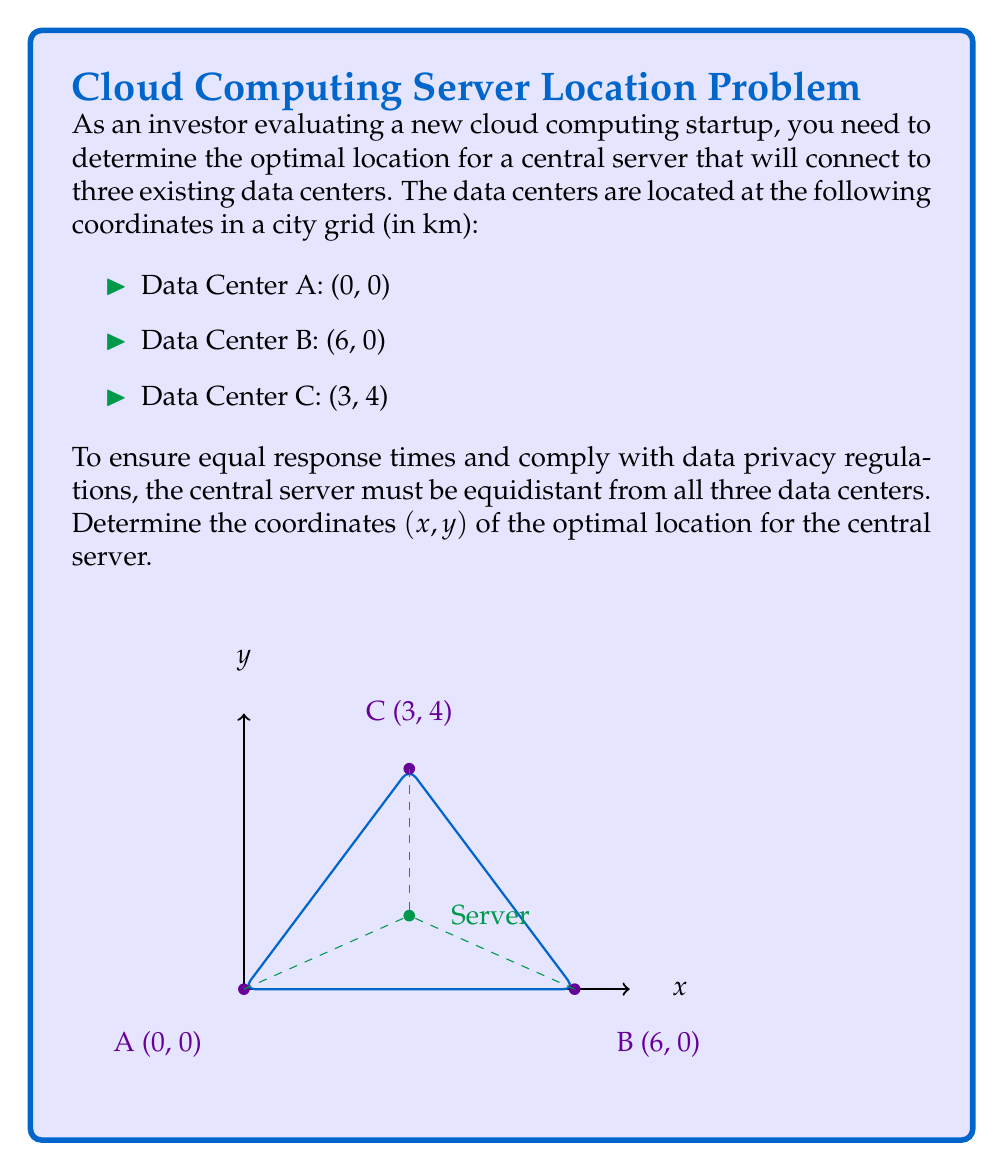Solve this math problem. Let's approach this step-by-step:

1) The point equidistant from three points in a plane is the center of the circle that passes through all three points. This is also known as the circumcenter of the triangle formed by the three points.

2) To find the circumcenter, we need to find the intersection of the perpendicular bisectors of any two sides of the triangle.

3) Let's choose sides AB and BC:

   Side AB: from (0,0) to (6,0)
   Side BC: from (6,0) to (3,4)

4) The midpoint of AB is (3,0). The perpendicular bisector of AB will have the equation x = 3.

5) For BC:
   Midpoint: $(\frac{6+3}{2}, \frac{0+4}{2}) = (4.5, 2)$
   Slope of BC: $m_{BC} = \frac{4-0}{3-6} = -\frac{4}{3}$
   Perpendicular slope: $m_{\perp} = \frac{3}{4}$

6) The equation of the perpendicular bisector of BC:
   $y - 2 = \frac{3}{4}(x - 4.5)$

7) To find the circumcenter, we solve the system of equations:
   $x = 3$
   $y - 2 = \frac{3}{4}(x - 4.5)$

8) Substituting x = 3 into the second equation:
   $y - 2 = \frac{3}{4}(3 - 4.5) = -\frac{9}{8}$
   $y = 2 - \frac{9}{8} = \frac{7}{8} = \frac{4}{3}$

9) Therefore, the coordinates of the circumcenter are $(3, \frac{4}{3})$.

10) To verify, we can calculate the distance from this point to each data center using the distance formula:
    $d = \sqrt{(x_2-x_1)^2 + (y_2-y_1)^2}$

    All three distances should be equal.
Answer: $(3, \frac{4}{3})$ 